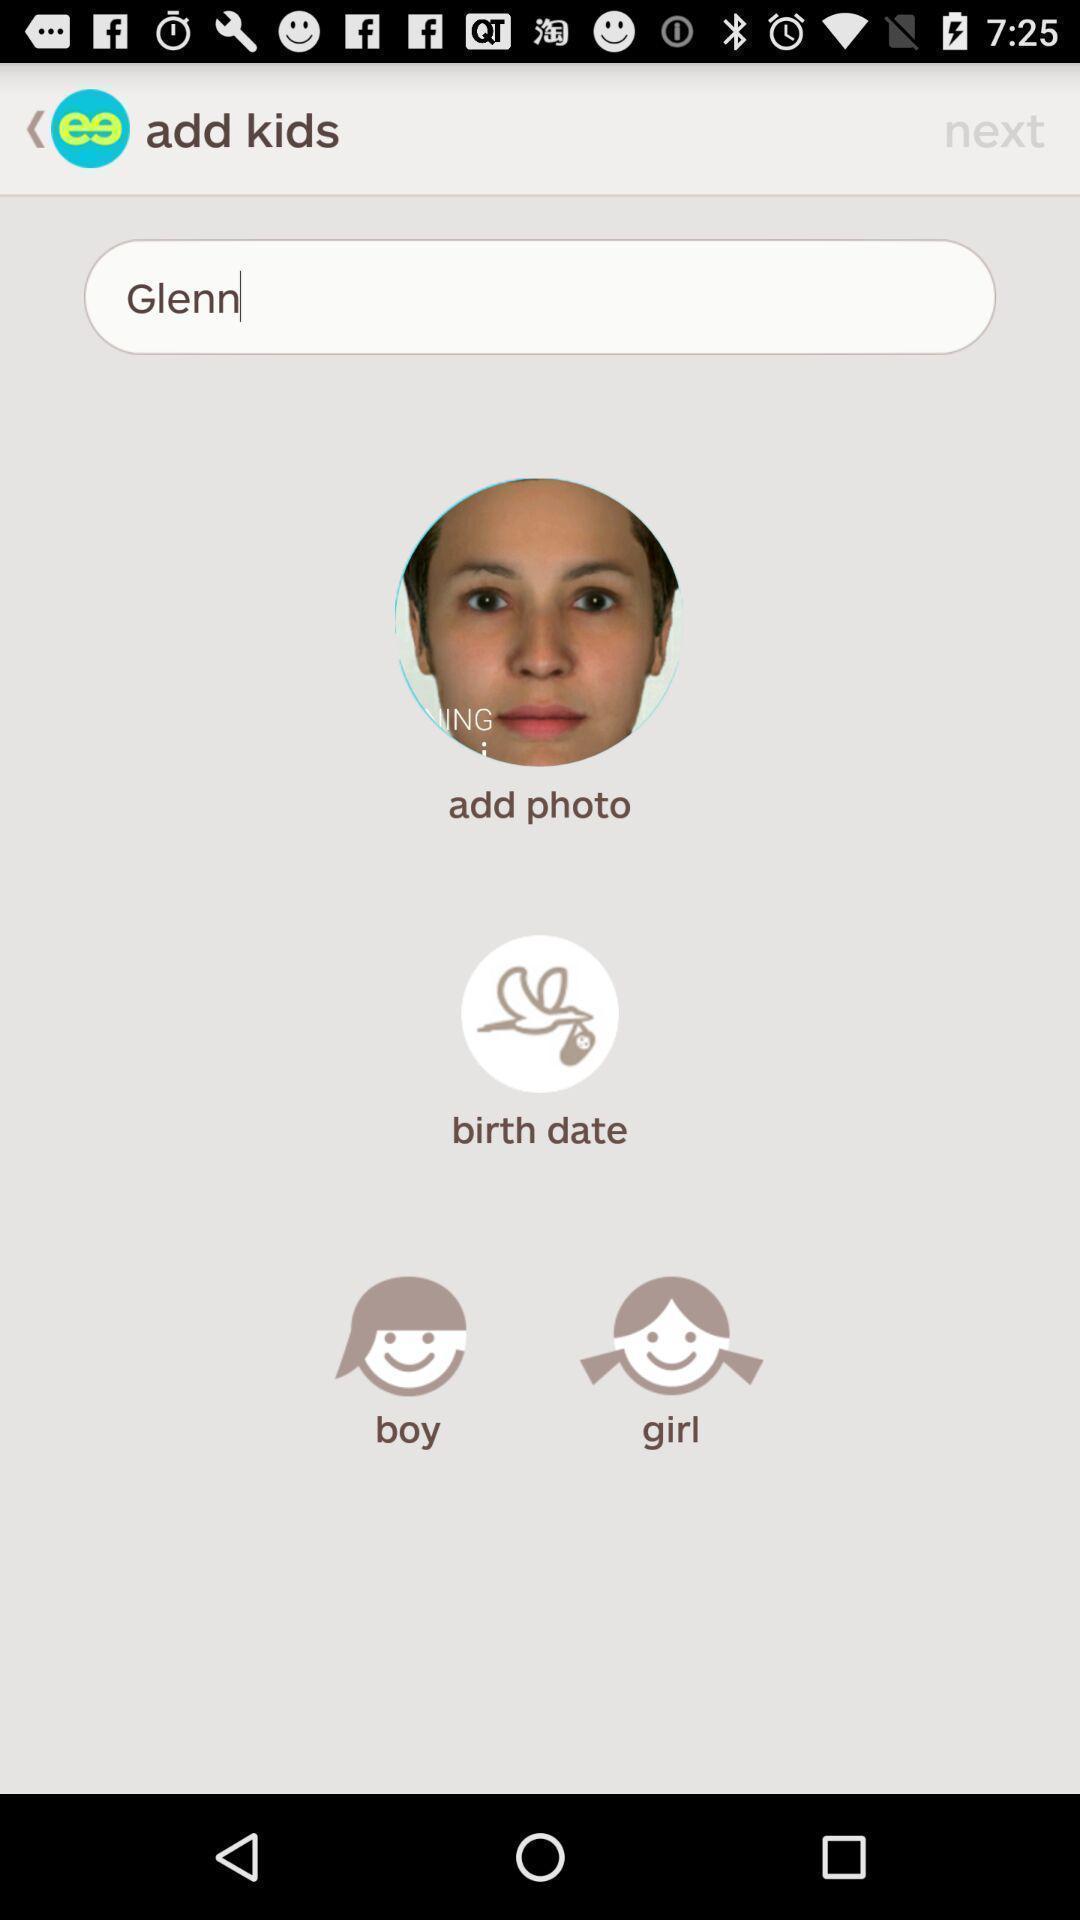Describe the visual elements of this screenshot. Screen showing add kids. 